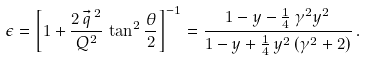Convert formula to latex. <formula><loc_0><loc_0><loc_500><loc_500>\epsilon = \left [ 1 + \frac { 2 \, \vec { q } ^ { \, 2 } } { Q ^ { 2 } } \, \tan ^ { 2 } \frac { \theta } { 2 } \right ] ^ { - 1 } = \frac { 1 - y - \frac { 1 } { 4 } \, \gamma ^ { 2 } y ^ { 2 } } { 1 - y + \frac { 1 } { 4 } \, y ^ { 2 } \, ( \gamma ^ { 2 } + 2 ) } \, .</formula> 